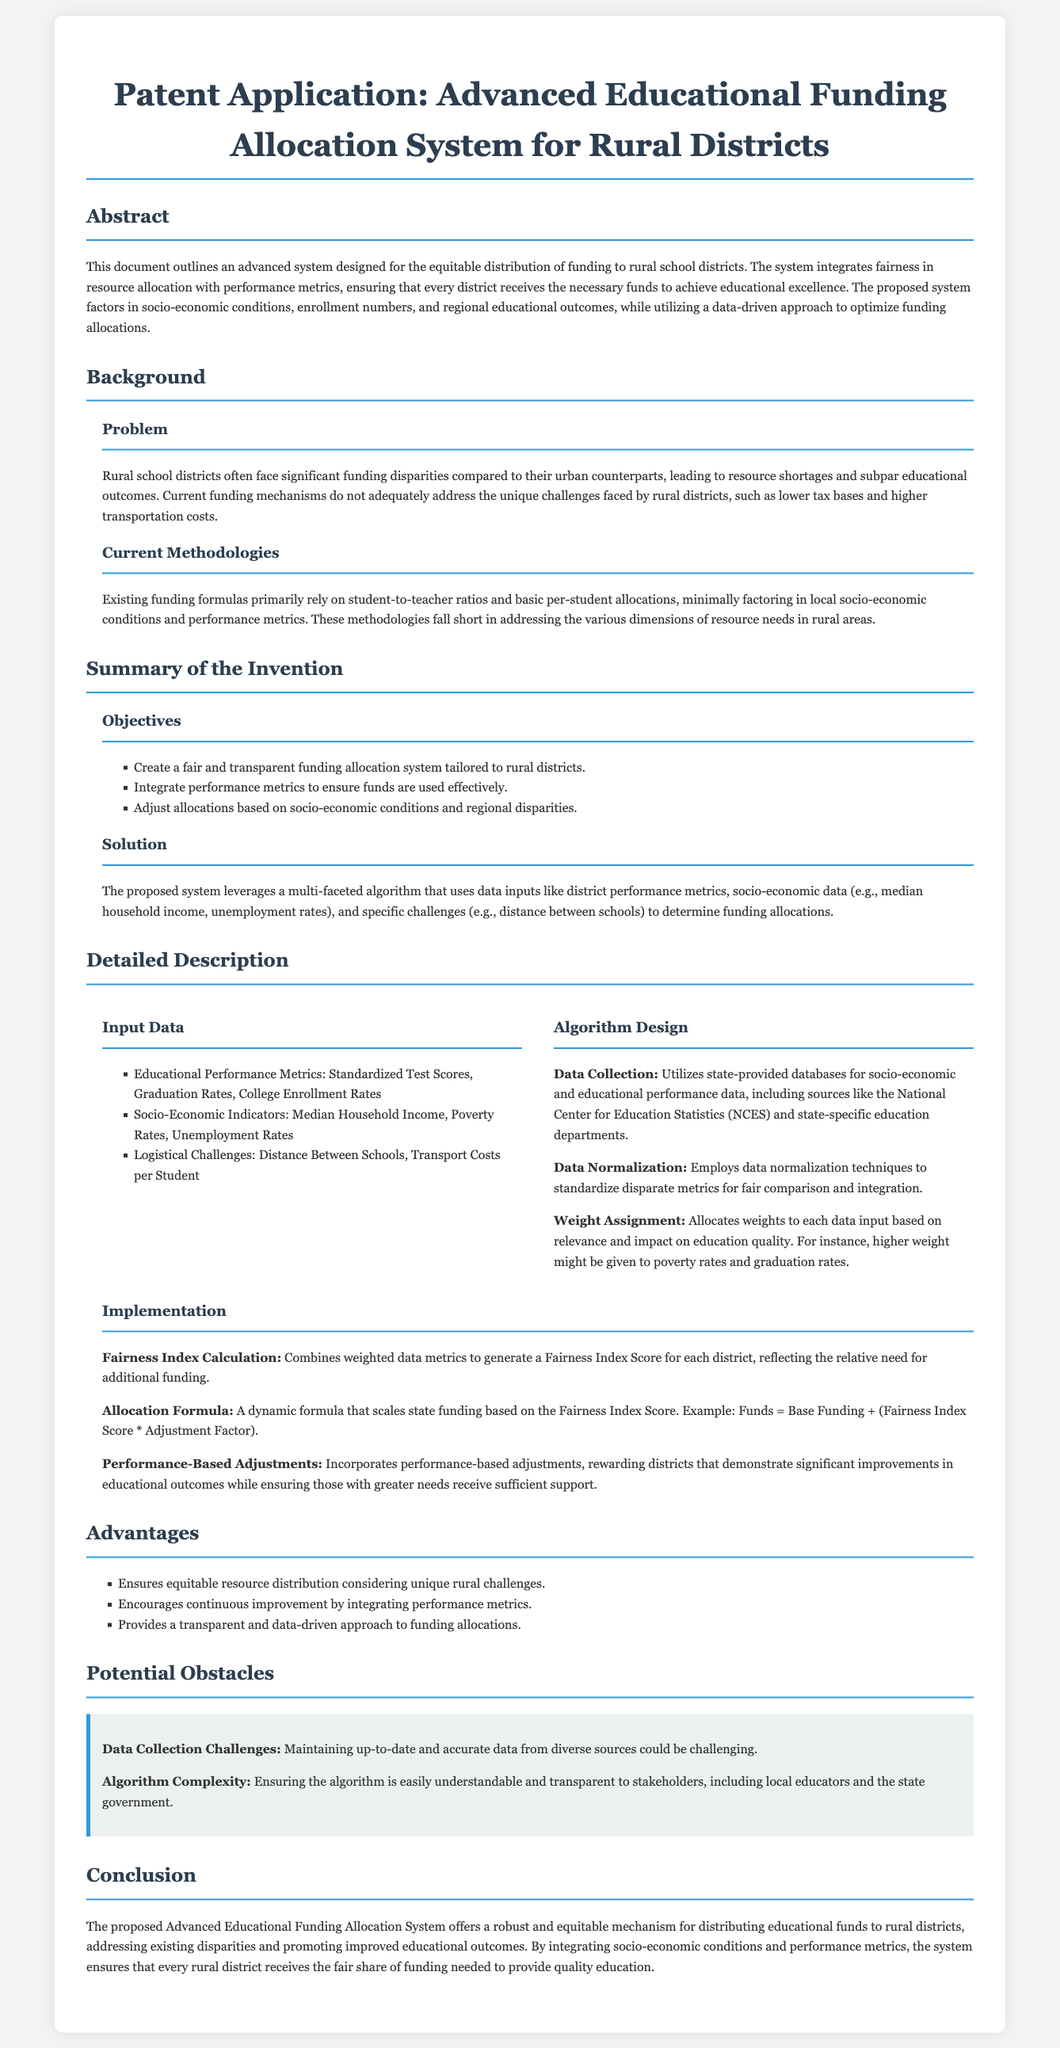what is the title of the patent application? The title of the patent application is stated at the beginning of the document.
Answer: Advanced Educational Funding Allocation System for Rural Districts what is the main problem addressed in this document? The document discusses significant funding disparities faced by rural school districts compared to urban ones.
Answer: Funding disparities what are the three objectives mentioned in the summary of the invention? The objectives are listed as bullet points in the document.
Answer: Fair and transparent funding, integrate performance metrics, adjust allocations how does the proposed system determine funding allocations? The solution section explains that funding allocations are determined using a multi-faceted algorithm with various data inputs.
Answer: Multi-faceted algorithm what are some input data types used in the system? Input data types are detailed in a subsection and include educational performance metrics and socio-economic indicators.
Answer: Educational performance metrics, socio-economic indicators what is the purpose of the Fairness Index Score? The document explains that the Fairness Index Score reflects the relative need for additional funding.
Answer: Reflects need for additional funding what potential obstacle involves data? The document highlights one of the potential obstacles regarding data.
Answer: Data collection challenges what advantages does the proposed system ensure? The advantages list outlines several benefits of the system as it is summarized in the document.
Answer: Equitable resource distribution what is the main conclusion drawn in the document? The conclusion outlines the overall effectiveness of the proposed system in addressing funding issues.
Answer: Robust and equitable mechanism what type of challenges does the document emphasize for rural districts? The background section identifies specific issues faced by rural districts as key challenges.
Answer: Resource shortages 